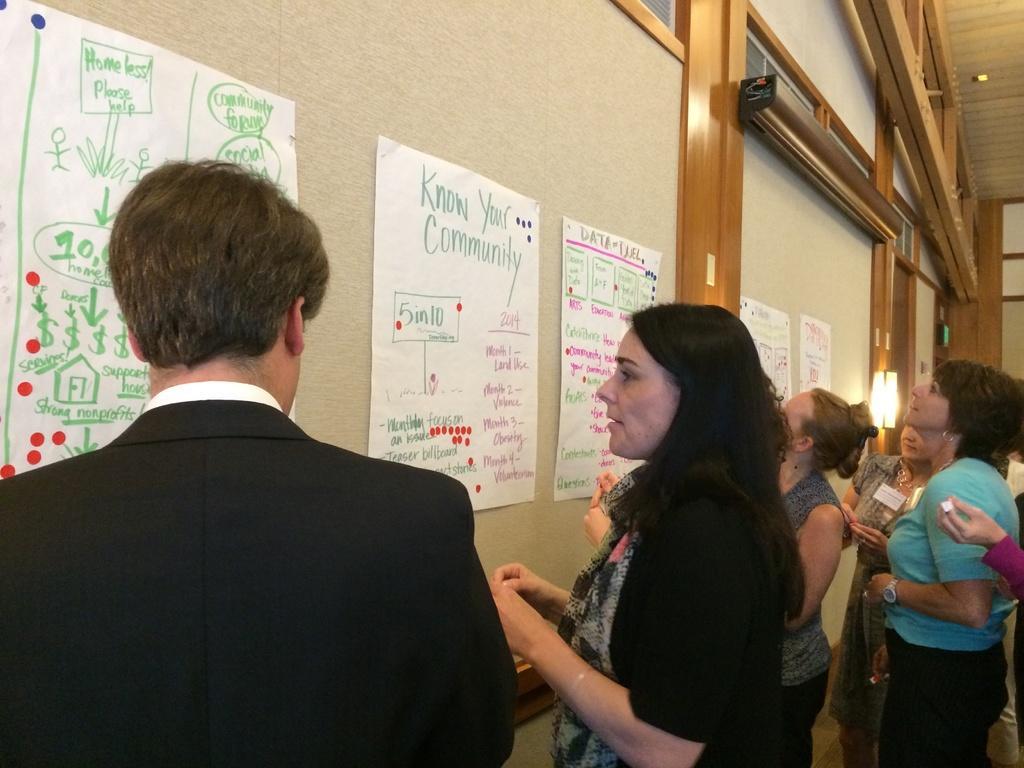In one or two sentences, can you explain what this image depicts? In this picture I can see group of people standing. There are pipes attached to the wall, and in the background there are some objects. 